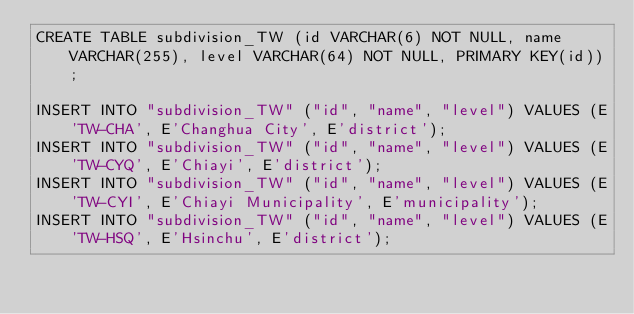<code> <loc_0><loc_0><loc_500><loc_500><_SQL_>CREATE TABLE subdivision_TW (id VARCHAR(6) NOT NULL, name VARCHAR(255), level VARCHAR(64) NOT NULL, PRIMARY KEY(id));

INSERT INTO "subdivision_TW" ("id", "name", "level") VALUES (E'TW-CHA', E'Changhua City', E'district');
INSERT INTO "subdivision_TW" ("id", "name", "level") VALUES (E'TW-CYQ', E'Chiayi', E'district');
INSERT INTO "subdivision_TW" ("id", "name", "level") VALUES (E'TW-CYI', E'Chiayi Municipality', E'municipality');
INSERT INTO "subdivision_TW" ("id", "name", "level") VALUES (E'TW-HSQ', E'Hsinchu', E'district');</code> 